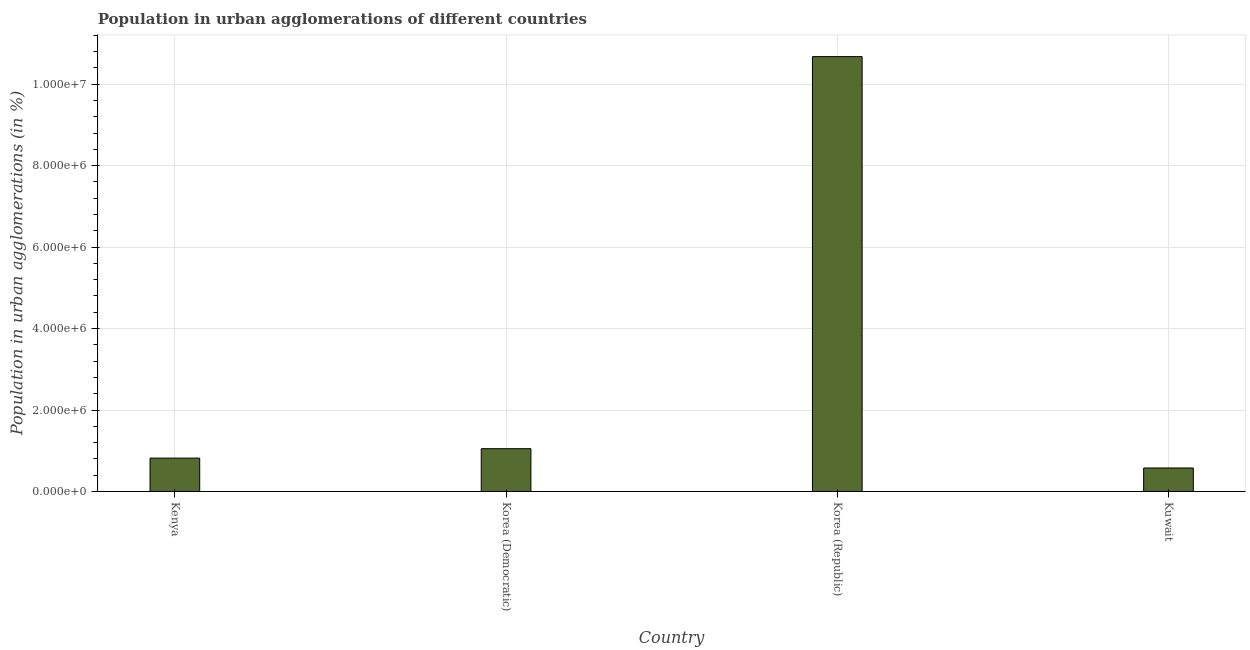Does the graph contain any zero values?
Keep it short and to the point. No. What is the title of the graph?
Make the answer very short. Population in urban agglomerations of different countries. What is the label or title of the X-axis?
Your answer should be very brief. Country. What is the label or title of the Y-axis?
Offer a very short reply. Population in urban agglomerations (in %). What is the population in urban agglomerations in Korea (Democratic)?
Keep it short and to the point. 1.05e+06. Across all countries, what is the maximum population in urban agglomerations?
Provide a short and direct response. 1.07e+07. Across all countries, what is the minimum population in urban agglomerations?
Keep it short and to the point. 5.77e+05. In which country was the population in urban agglomerations maximum?
Keep it short and to the point. Korea (Republic). In which country was the population in urban agglomerations minimum?
Provide a succinct answer. Kuwait. What is the sum of the population in urban agglomerations?
Your answer should be very brief. 1.31e+07. What is the difference between the population in urban agglomerations in Korea (Republic) and Kuwait?
Provide a succinct answer. 1.01e+07. What is the average population in urban agglomerations per country?
Provide a succinct answer. 3.28e+06. What is the median population in urban agglomerations?
Make the answer very short. 9.35e+05. What is the ratio of the population in urban agglomerations in Kenya to that in Korea (Republic)?
Provide a short and direct response. 0.08. Is the difference between the population in urban agglomerations in Kenya and Korea (Democratic) greater than the difference between any two countries?
Offer a very short reply. No. What is the difference between the highest and the second highest population in urban agglomerations?
Keep it short and to the point. 9.63e+06. Is the sum of the population in urban agglomerations in Kenya and Korea (Republic) greater than the maximum population in urban agglomerations across all countries?
Your response must be concise. Yes. What is the difference between the highest and the lowest population in urban agglomerations?
Provide a succinct answer. 1.01e+07. Are all the bars in the graph horizontal?
Offer a very short reply. No. What is the difference between two consecutive major ticks on the Y-axis?
Provide a short and direct response. 2.00e+06. Are the values on the major ticks of Y-axis written in scientific E-notation?
Your answer should be very brief. Yes. What is the Population in urban agglomerations (in %) in Kenya?
Provide a short and direct response. 8.19e+05. What is the Population in urban agglomerations (in %) in Korea (Democratic)?
Offer a terse response. 1.05e+06. What is the Population in urban agglomerations (in %) in Korea (Republic)?
Give a very brief answer. 1.07e+07. What is the Population in urban agglomerations (in %) in Kuwait?
Your answer should be compact. 5.77e+05. What is the difference between the Population in urban agglomerations (in %) in Kenya and Korea (Democratic)?
Make the answer very short. -2.31e+05. What is the difference between the Population in urban agglomerations (in %) in Kenya and Korea (Republic)?
Offer a very short reply. -9.86e+06. What is the difference between the Population in urban agglomerations (in %) in Kenya and Kuwait?
Your answer should be very brief. 2.42e+05. What is the difference between the Population in urban agglomerations (in %) in Korea (Democratic) and Korea (Republic)?
Make the answer very short. -9.63e+06. What is the difference between the Population in urban agglomerations (in %) in Korea (Democratic) and Kuwait?
Provide a short and direct response. 4.73e+05. What is the difference between the Population in urban agglomerations (in %) in Korea (Republic) and Kuwait?
Give a very brief answer. 1.01e+07. What is the ratio of the Population in urban agglomerations (in %) in Kenya to that in Korea (Democratic)?
Make the answer very short. 0.78. What is the ratio of the Population in urban agglomerations (in %) in Kenya to that in Korea (Republic)?
Keep it short and to the point. 0.08. What is the ratio of the Population in urban agglomerations (in %) in Kenya to that in Kuwait?
Your response must be concise. 1.42. What is the ratio of the Population in urban agglomerations (in %) in Korea (Democratic) to that in Korea (Republic)?
Make the answer very short. 0.1. What is the ratio of the Population in urban agglomerations (in %) in Korea (Democratic) to that in Kuwait?
Make the answer very short. 1.82. What is the ratio of the Population in urban agglomerations (in %) in Korea (Republic) to that in Kuwait?
Offer a very short reply. 18.5. 